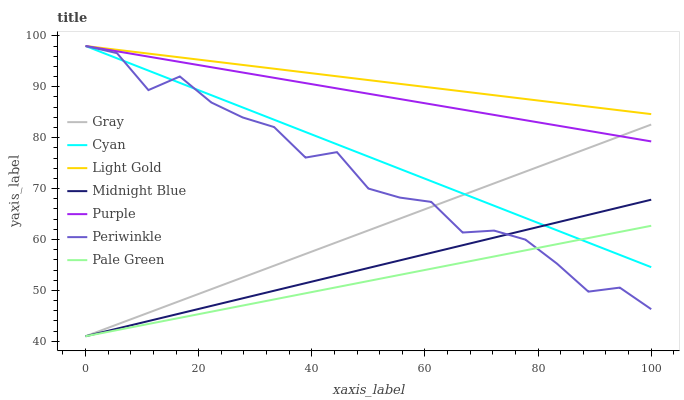Does Midnight Blue have the minimum area under the curve?
Answer yes or no. No. Does Midnight Blue have the maximum area under the curve?
Answer yes or no. No. Is Purple the smoothest?
Answer yes or no. No. Is Purple the roughest?
Answer yes or no. No. Does Purple have the lowest value?
Answer yes or no. No. Does Midnight Blue have the highest value?
Answer yes or no. No. Is Pale Green less than Purple?
Answer yes or no. Yes. Is Light Gold greater than Midnight Blue?
Answer yes or no. Yes. Does Pale Green intersect Purple?
Answer yes or no. No. 